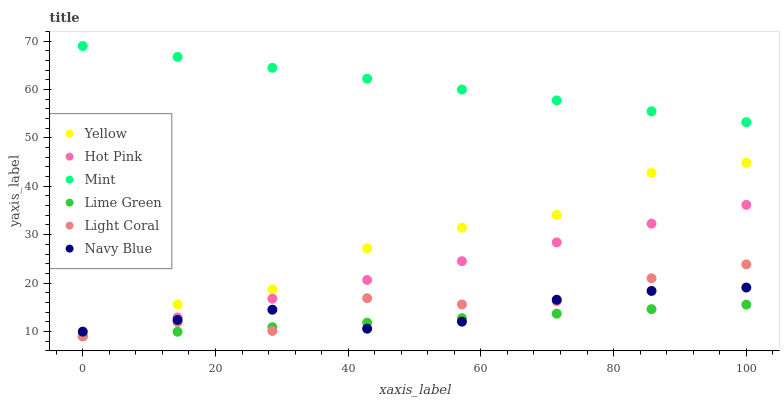Does Lime Green have the minimum area under the curve?
Answer yes or no. Yes. Does Mint have the maximum area under the curve?
Answer yes or no. Yes. Does Hot Pink have the minimum area under the curve?
Answer yes or no. No. Does Hot Pink have the maximum area under the curve?
Answer yes or no. No. Is Mint the smoothest?
Answer yes or no. Yes. Is Light Coral the roughest?
Answer yes or no. Yes. Is Hot Pink the smoothest?
Answer yes or no. No. Is Hot Pink the roughest?
Answer yes or no. No. Does Hot Pink have the lowest value?
Answer yes or no. Yes. Does Navy Blue have the lowest value?
Answer yes or no. No. Does Mint have the highest value?
Answer yes or no. Yes. Does Hot Pink have the highest value?
Answer yes or no. No. Is Lime Green less than Mint?
Answer yes or no. Yes. Is Mint greater than Navy Blue?
Answer yes or no. Yes. Does Navy Blue intersect Hot Pink?
Answer yes or no. Yes. Is Navy Blue less than Hot Pink?
Answer yes or no. No. Is Navy Blue greater than Hot Pink?
Answer yes or no. No. Does Lime Green intersect Mint?
Answer yes or no. No. 